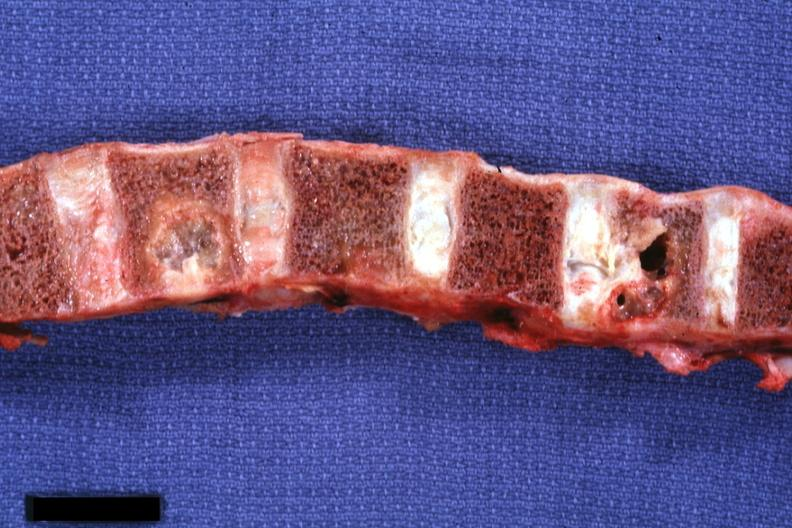s joints present?
Answer the question using a single word or phrase. Yes 